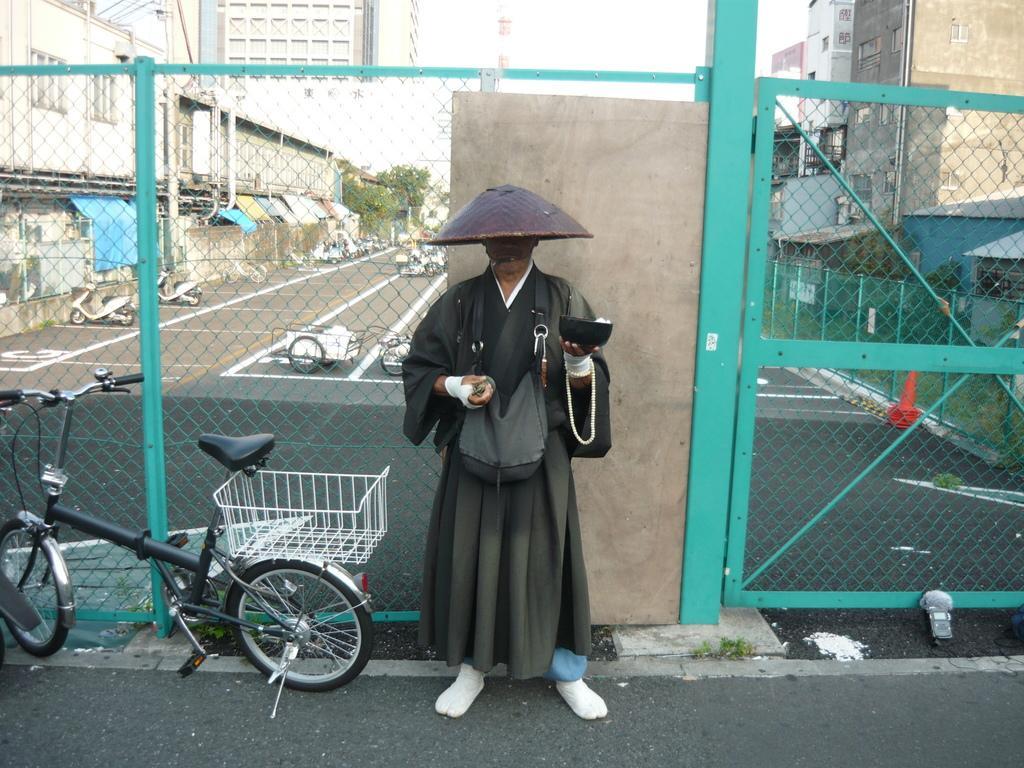Please provide a concise description of this image. In this image we can see a person wearing black color dress holding a bowl in his hands and also wearing cap and at the background of the image there is fencing and some vehicles, buildings and trees, at the foreground of the image there is bicycle. 